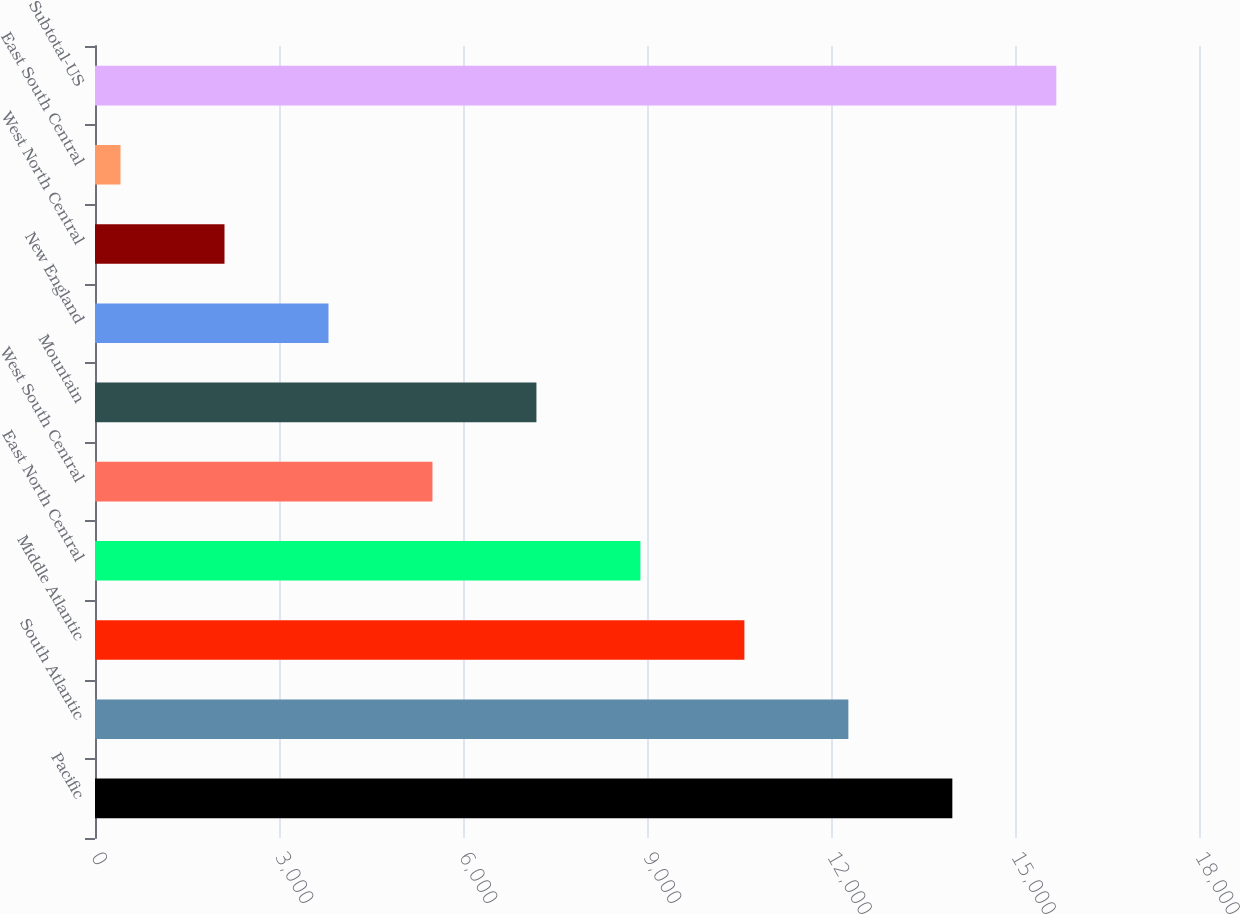Convert chart. <chart><loc_0><loc_0><loc_500><loc_500><bar_chart><fcel>Pacific<fcel>South Atlantic<fcel>Middle Atlantic<fcel>East North Central<fcel>West South Central<fcel>Mountain<fcel>New England<fcel>West North Central<fcel>East South Central<fcel>Subtotal-US<nl><fcel>13978.4<fcel>12283.1<fcel>10587.8<fcel>8892.5<fcel>5501.9<fcel>7197.2<fcel>3806.6<fcel>2111.3<fcel>416<fcel>15673.7<nl></chart> 